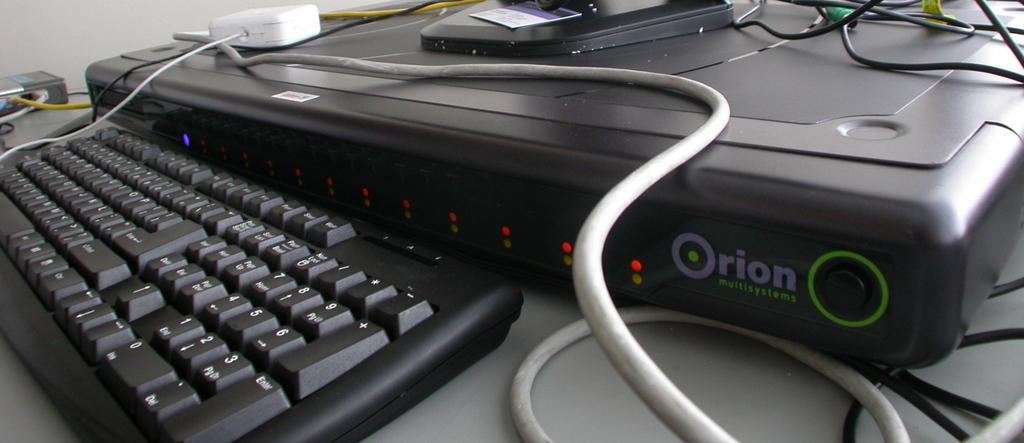<image>
Write a terse but informative summary of the picture. A keyboard and some other sort of electronic device that says Orion. 